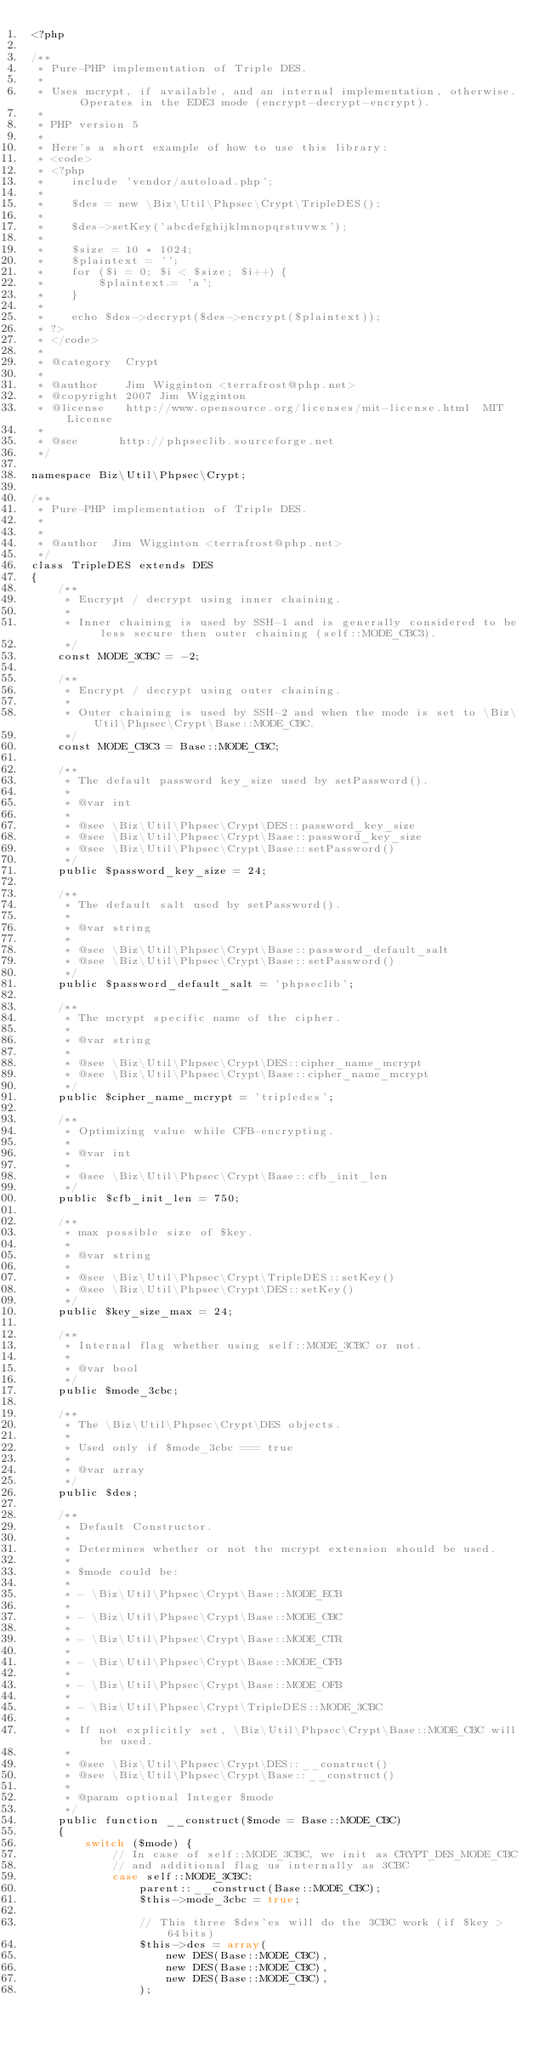<code> <loc_0><loc_0><loc_500><loc_500><_PHP_><?php

/**
 * Pure-PHP implementation of Triple DES.
 *
 * Uses mcrypt, if available, and an internal implementation, otherwise.  Operates in the EDE3 mode (encrypt-decrypt-encrypt).
 *
 * PHP version 5
 *
 * Here's a short example of how to use this library:
 * <code>
 * <?php
 *    include 'vendor/autoload.php';
 *
 *    $des = new \Biz\Util\Phpsec\Crypt\TripleDES();
 *
 *    $des->setKey('abcdefghijklmnopqrstuvwx');
 *
 *    $size = 10 * 1024;
 *    $plaintext = '';
 *    for ($i = 0; $i < $size; $i++) {
 *        $plaintext.= 'a';
 *    }
 *
 *    echo $des->decrypt($des->encrypt($plaintext));
 * ?>
 * </code>
 *
 * @category  Crypt
 *
 * @author    Jim Wigginton <terrafrost@php.net>
 * @copyright 2007 Jim Wigginton
 * @license   http://www.opensource.org/licenses/mit-license.html  MIT License
 *
 * @see      http://phpseclib.sourceforge.net
 */

namespace Biz\Util\Phpsec\Crypt;

/**
 * Pure-PHP implementation of Triple DES.
 *
 *
 * @author  Jim Wigginton <terrafrost@php.net>
 */
class TripleDES extends DES
{
    /**
     * Encrypt / decrypt using inner chaining.
     *
     * Inner chaining is used by SSH-1 and is generally considered to be less secure then outer chaining (self::MODE_CBC3).
     */
    const MODE_3CBC = -2;

    /**
     * Encrypt / decrypt using outer chaining.
     *
     * Outer chaining is used by SSH-2 and when the mode is set to \Biz\Util\Phpsec\Crypt\Base::MODE_CBC.
     */
    const MODE_CBC3 = Base::MODE_CBC;

    /**
     * The default password key_size used by setPassword().
     *
     * @var int
     *
     * @see \Biz\Util\Phpsec\Crypt\DES::password_key_size
     * @see \Biz\Util\Phpsec\Crypt\Base::password_key_size
     * @see \Biz\Util\Phpsec\Crypt\Base::setPassword()
     */
    public $password_key_size = 24;

    /**
     * The default salt used by setPassword().
     *
     * @var string
     *
     * @see \Biz\Util\Phpsec\Crypt\Base::password_default_salt
     * @see \Biz\Util\Phpsec\Crypt\Base::setPassword()
     */
    public $password_default_salt = 'phpseclib';

    /**
     * The mcrypt specific name of the cipher.
     *
     * @var string
     *
     * @see \Biz\Util\Phpsec\Crypt\DES::cipher_name_mcrypt
     * @see \Biz\Util\Phpsec\Crypt\Base::cipher_name_mcrypt
     */
    public $cipher_name_mcrypt = 'tripledes';

    /**
     * Optimizing value while CFB-encrypting.
     *
     * @var int
     *
     * @see \Biz\Util\Phpsec\Crypt\Base::cfb_init_len
     */
    public $cfb_init_len = 750;

    /**
     * max possible size of $key.
     *
     * @var string
     *
     * @see \Biz\Util\Phpsec\Crypt\TripleDES::setKey()
     * @see \Biz\Util\Phpsec\Crypt\DES::setKey()
     */
    public $key_size_max = 24;

    /**
     * Internal flag whether using self::MODE_3CBC or not.
     *
     * @var bool
     */
    public $mode_3cbc;

    /**
     * The \Biz\Util\Phpsec\Crypt\DES objects.
     *
     * Used only if $mode_3cbc === true
     *
     * @var array
     */
    public $des;

    /**
     * Default Constructor.
     *
     * Determines whether or not the mcrypt extension should be used.
     *
     * $mode could be:
     *
     * - \Biz\Util\Phpsec\Crypt\Base::MODE_ECB
     *
     * - \Biz\Util\Phpsec\Crypt\Base::MODE_CBC
     *
     * - \Biz\Util\Phpsec\Crypt\Base::MODE_CTR
     *
     * - \Biz\Util\Phpsec\Crypt\Base::MODE_CFB
     *
     * - \Biz\Util\Phpsec\Crypt\Base::MODE_OFB
     *
     * - \Biz\Util\Phpsec\Crypt\TripleDES::MODE_3CBC
     *
     * If not explicitly set, \Biz\Util\Phpsec\Crypt\Base::MODE_CBC will be used.
     *
     * @see \Biz\Util\Phpsec\Crypt\DES::__construct()
     * @see \Biz\Util\Phpsec\Crypt\Base::__construct()
     *
     * @param optional Integer $mode
     */
    public function __construct($mode = Base::MODE_CBC)
    {
        switch ($mode) {
            // In case of self::MODE_3CBC, we init as CRYPT_DES_MODE_CBC
            // and additional flag us internally as 3CBC
            case self::MODE_3CBC:
                parent::__construct(Base::MODE_CBC);
                $this->mode_3cbc = true;

                // This three $des'es will do the 3CBC work (if $key > 64bits)
                $this->des = array(
                    new DES(Base::MODE_CBC),
                    new DES(Base::MODE_CBC),
                    new DES(Base::MODE_CBC),
                );
</code> 